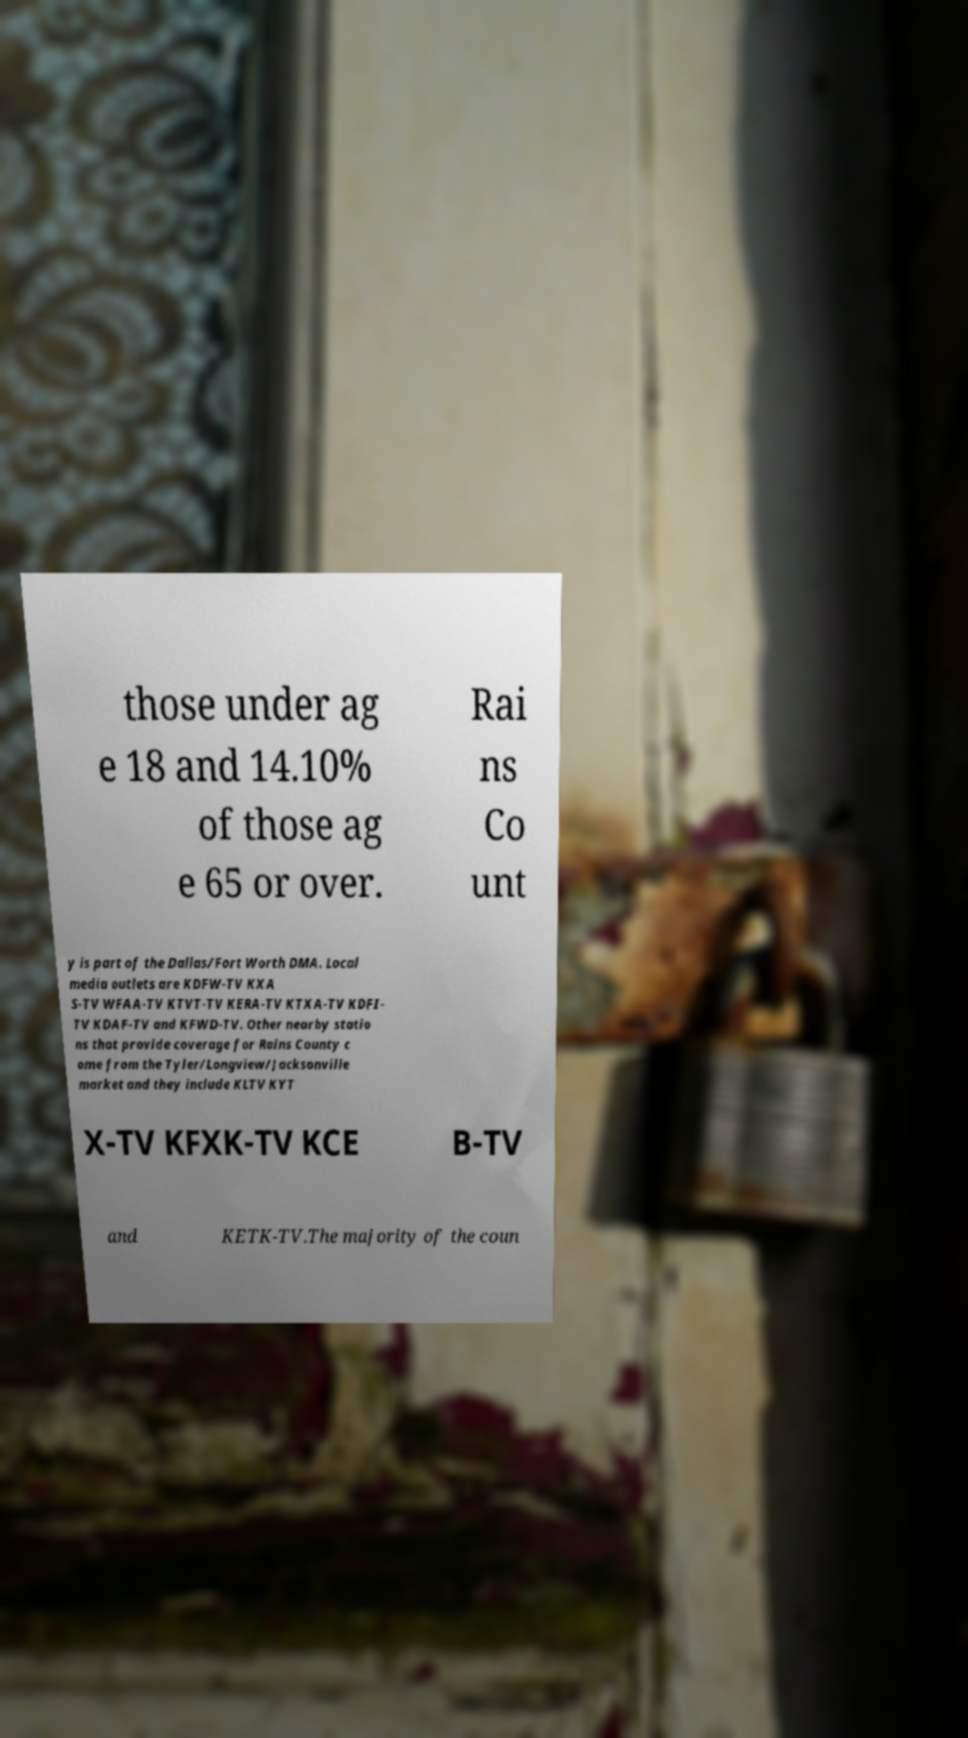I need the written content from this picture converted into text. Can you do that? those under ag e 18 and 14.10% of those ag e 65 or over. Rai ns Co unt y is part of the Dallas/Fort Worth DMA. Local media outlets are KDFW-TV KXA S-TV WFAA-TV KTVT-TV KERA-TV KTXA-TV KDFI- TV KDAF-TV and KFWD-TV. Other nearby statio ns that provide coverage for Rains County c ome from the Tyler/Longview/Jacksonville market and they include KLTV KYT X-TV KFXK-TV KCE B-TV and KETK-TV.The majority of the coun 